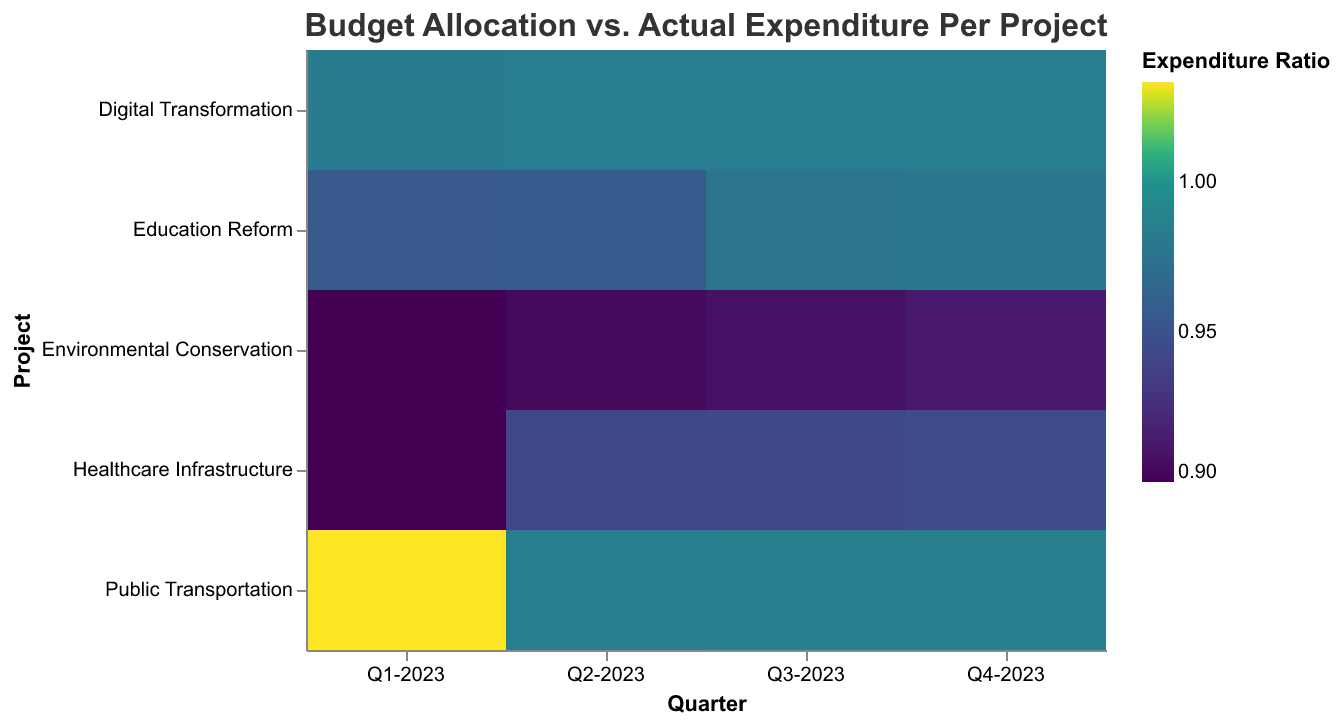What is the title of the heatmap? The title of the heatmap is usually located at the top and it provides an overall description of the visualization. The title in this case is "Budget Allocation vs. Actual Expenditure Per Project".
Answer: Budget Allocation vs. Actual Expenditure Per Project Which project had the highest expenditure ratio in Q1-2023? Look at the color corresponding to each project in Q1-2023 and find the one with the darkest color, indicating the highest expenditure ratio.
Answer: Digital Transformation What is the expenditure ratio for Education Reform in Q3-2023? Move to the intersection of Education Reform and Q3-2023, and look at the tooltip for the expenditure ratio.
Answer: 0.98 Which quarter shows the most significant under-expenditure for the Environmental Conservation project? Compare the colors across all quarters for the Environmental Conservation project and choose the lightest color, which indicates the lowest expenditure ratio.
Answer: Q1-2023 Did Public Transportation ever exceed its budget allocation? Refer to the color spectrum to see if any of the colors for Public Transportation projects are slightly above the mid-point (where the expenditure ratio is 1).
Answer: Yes, in Q1-2023 Which project had the most consistent expenditure ratio across all quarters? Compare the color pattern for each project across all quarters and identify the one with the least variation in color shades.
Answer: Digital Transformation What is the average actual expenditure for the Healthcare Infrastructure project? Sum up the actual expenditures for Healthcare Infrastructure across all quarters and divide by the number of quarters.
Answer: (450000 + 490000 + 500000 + 520000) / 4 = 490000 How does the expenditure ratio for Healthcare Infrastructure in Q2-2023 compare to Q4-2023? Compare the color for Healthcare Infrastructure in Q2-2023 and Q4-2023 and observe which one has a darker shade (indicating a higher ratio).
Answer: Q4-2023 is higher Which project generally underspends across all quarters? Look across all projects for the one with generally lighter shades indicating lower expenditure ratios.
Answer: Environmental Conservation 